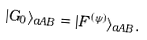<formula> <loc_0><loc_0><loc_500><loc_500>| G _ { 0 } \rangle _ { a A B } = | F ^ { ( \psi ) } \rangle _ { a A B } .</formula> 